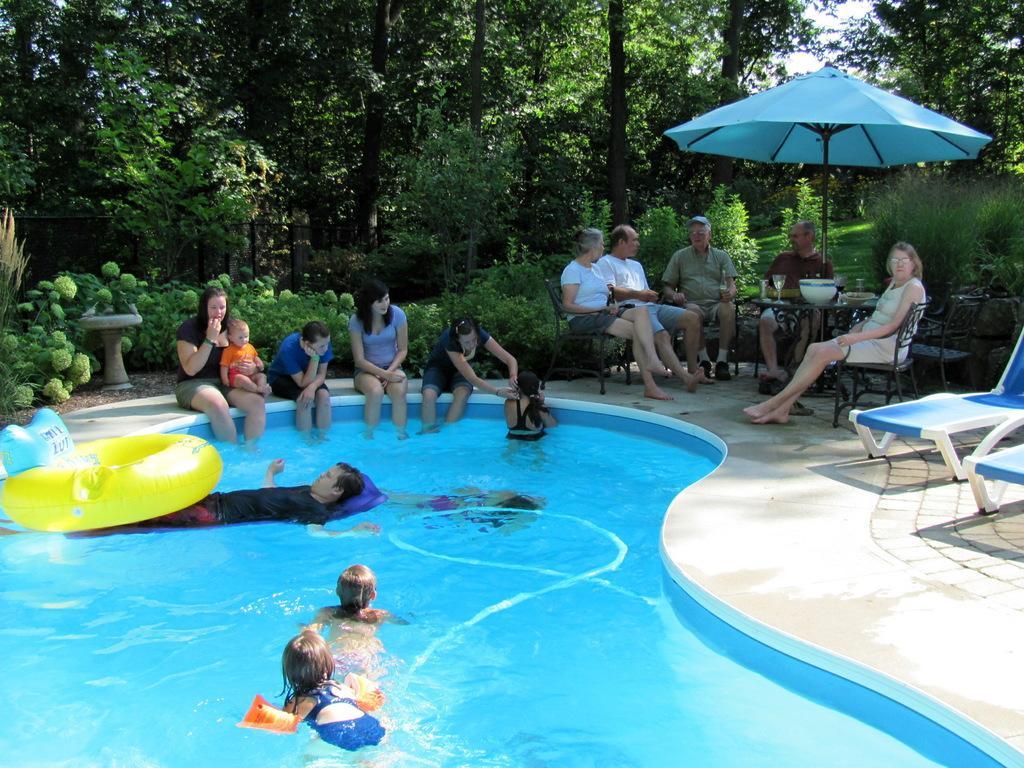In one or two sentences, can you explain what this image depicts? In this image I can see at the bottom few people are swimming in the swimming pool. In the middle few people are sitting, on the right side few people are sitting on the chairs under an umbrella. At the back side there are trees. 